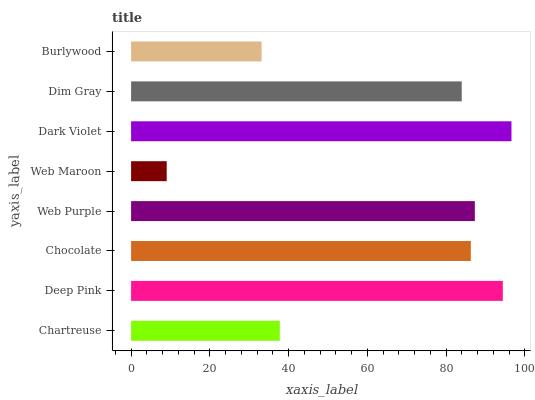Is Web Maroon the minimum?
Answer yes or no. Yes. Is Dark Violet the maximum?
Answer yes or no. Yes. Is Deep Pink the minimum?
Answer yes or no. No. Is Deep Pink the maximum?
Answer yes or no. No. Is Deep Pink greater than Chartreuse?
Answer yes or no. Yes. Is Chartreuse less than Deep Pink?
Answer yes or no. Yes. Is Chartreuse greater than Deep Pink?
Answer yes or no. No. Is Deep Pink less than Chartreuse?
Answer yes or no. No. Is Chocolate the high median?
Answer yes or no. Yes. Is Dim Gray the low median?
Answer yes or no. Yes. Is Web Purple the high median?
Answer yes or no. No. Is Deep Pink the low median?
Answer yes or no. No. 